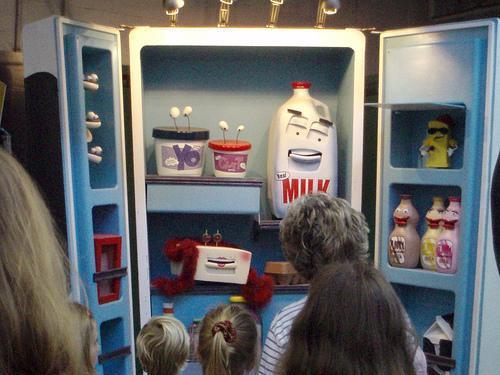How many people are in this picture?
Give a very brief answer. 6. How many brown bottles are there?
Give a very brief answer. 1. 